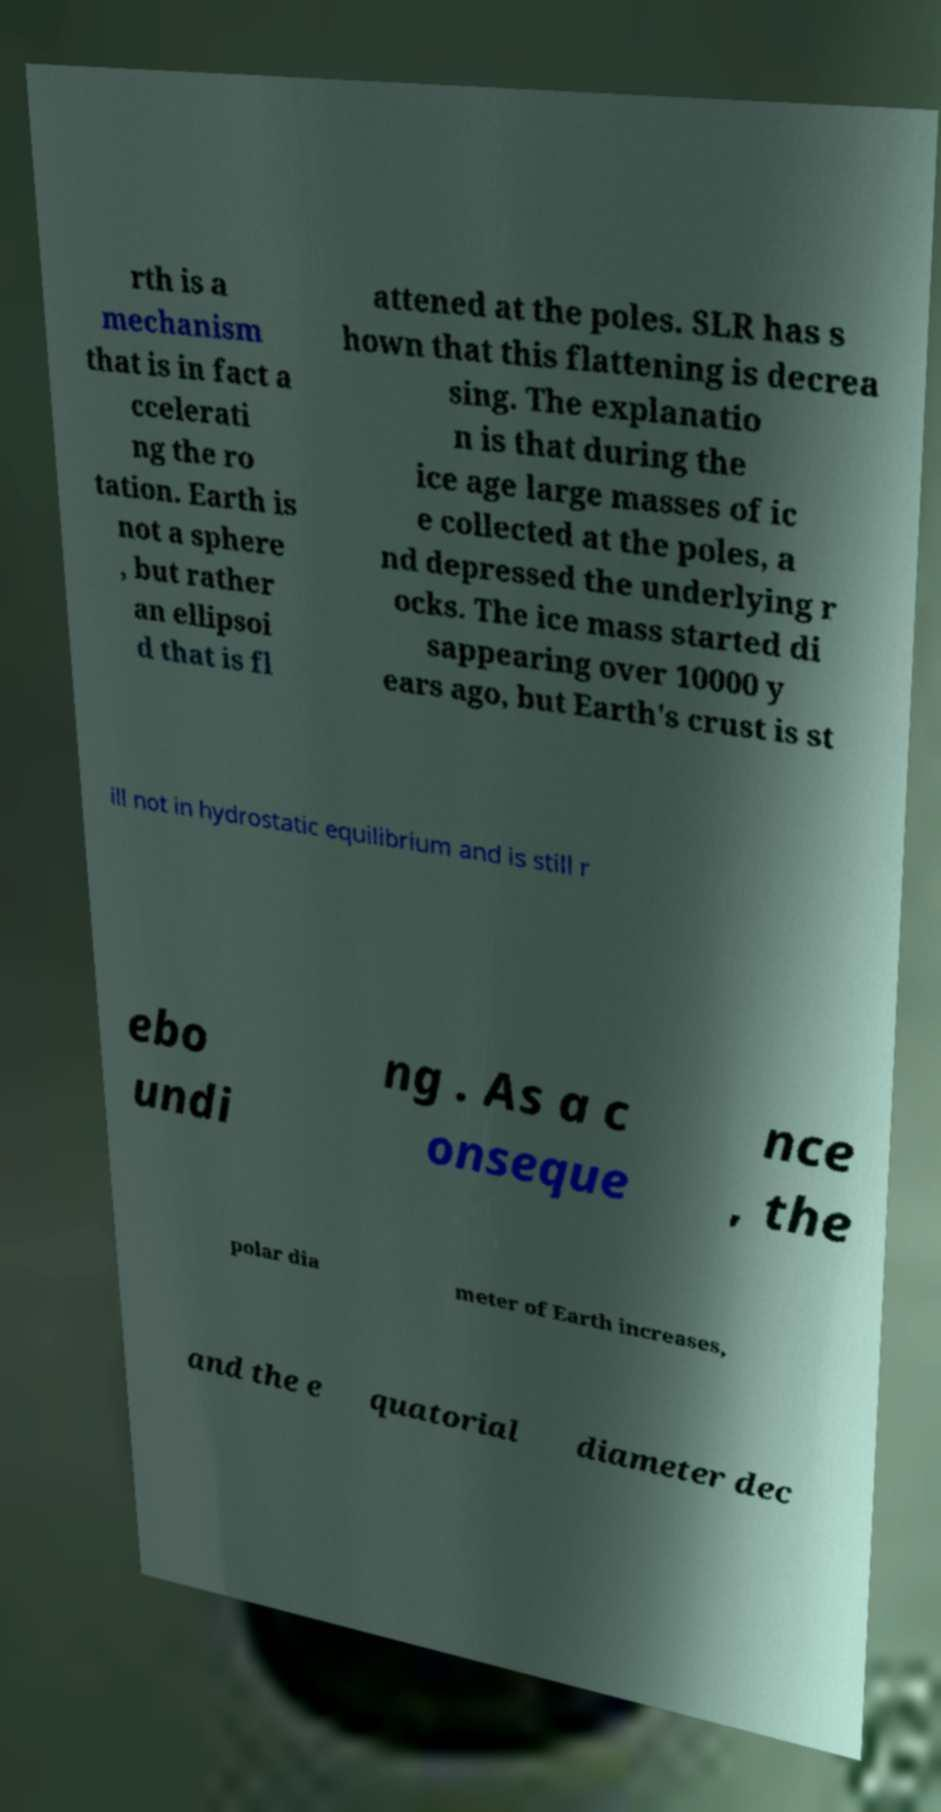Please identify and transcribe the text found in this image. rth is a mechanism that is in fact a ccelerati ng the ro tation. Earth is not a sphere , but rather an ellipsoi d that is fl attened at the poles. SLR has s hown that this flattening is decrea sing. The explanatio n is that during the ice age large masses of ic e collected at the poles, a nd depressed the underlying r ocks. The ice mass started di sappearing over 10000 y ears ago, but Earth's crust is st ill not in hydrostatic equilibrium and is still r ebo undi ng . As a c onseque nce , the polar dia meter of Earth increases, and the e quatorial diameter dec 